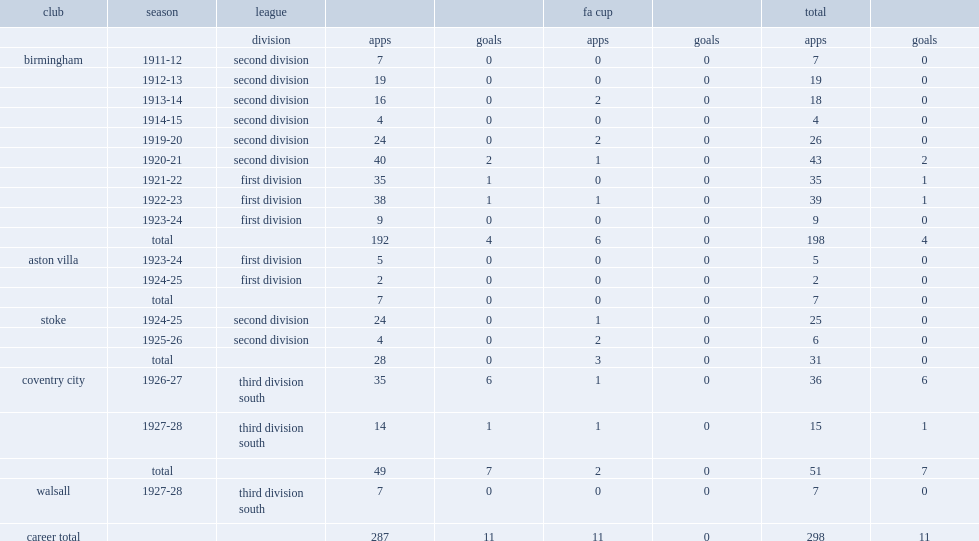How many appearances did alec mcclure play for birmingham and make? 198.0. 